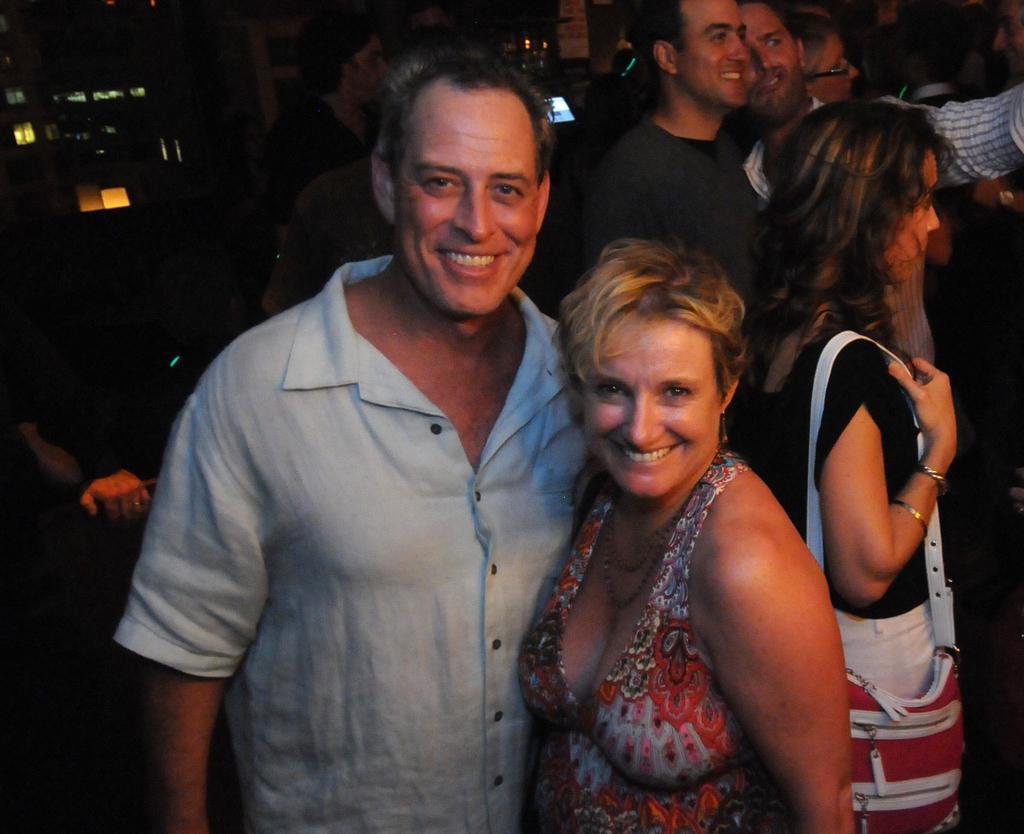Describe this image in one or two sentences. In this image there are a few people standing. In the foreground there is a man and a woman standing. They are smiling. The background is dark. 